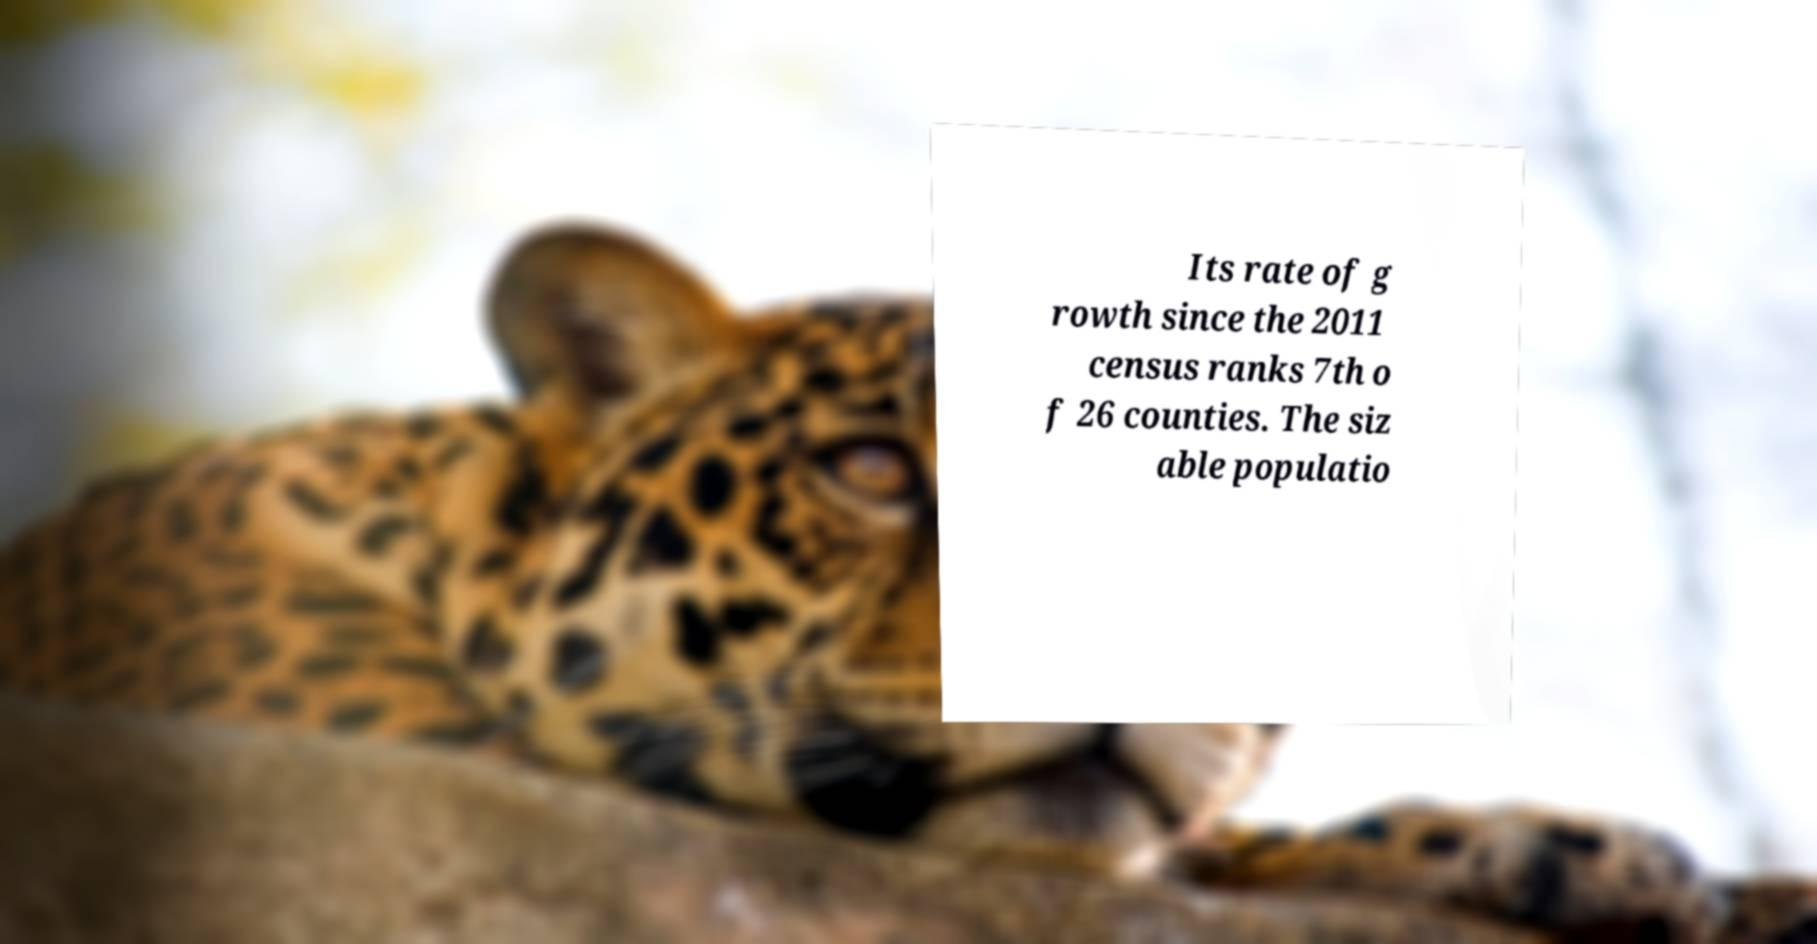Can you read and provide the text displayed in the image?This photo seems to have some interesting text. Can you extract and type it out for me? Its rate of g rowth since the 2011 census ranks 7th o f 26 counties. The siz able populatio 